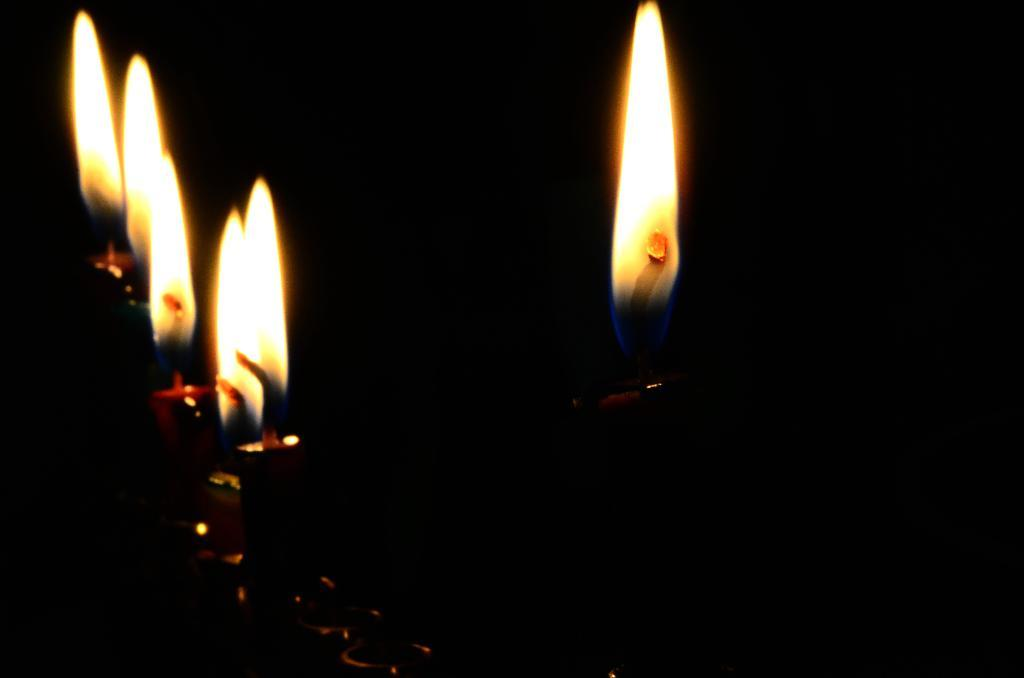What objects in the image have flames? There are candles with flames in the image. How would you describe the lighting in the image? The background of the image is dark. What type of toys can be seen on the desk in the image? There is no desk or toys present in the image; it only features candles with flames and a dark background. 